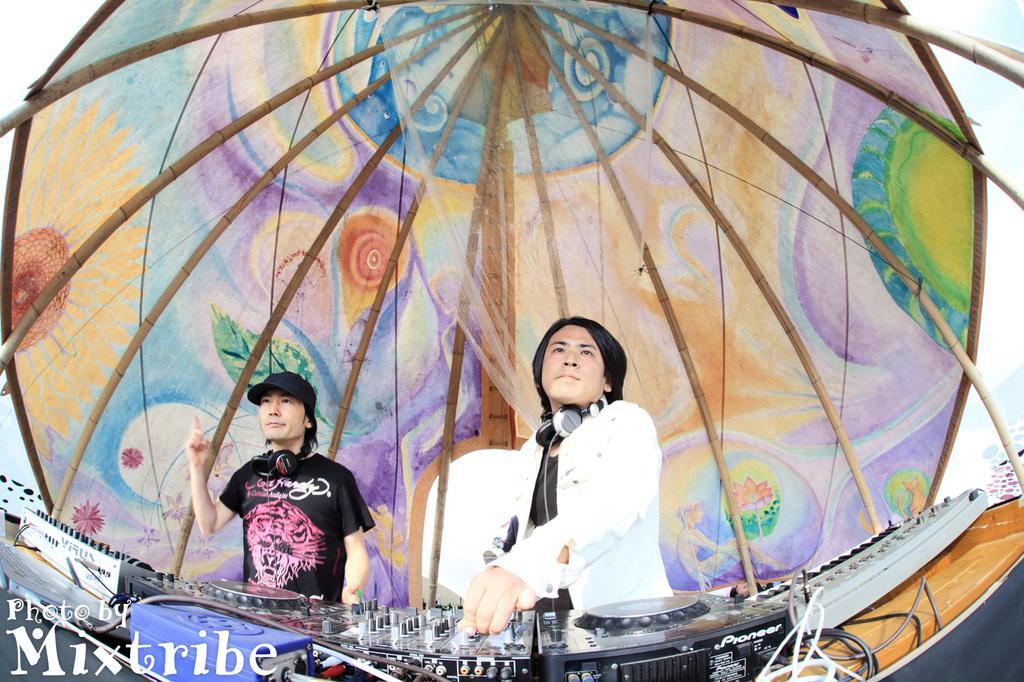Can you describe this image briefly? In this picture I can see two persons are controlling the DJs in the middle. There is the watermark in the bottom left hand side, at the top it looks like an umbrella. 